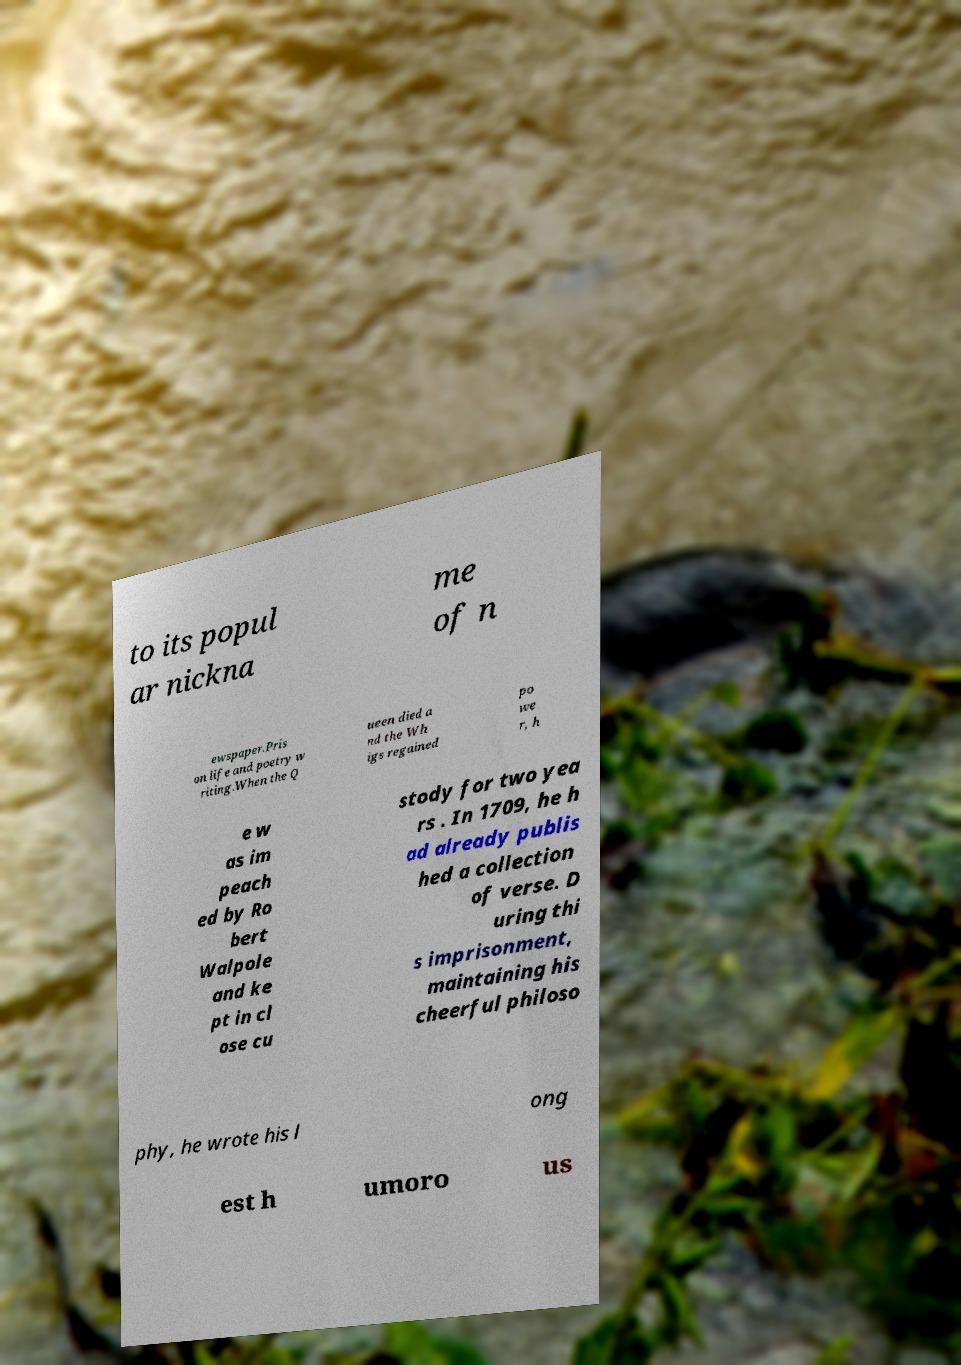Could you assist in decoding the text presented in this image and type it out clearly? to its popul ar nickna me of n ewspaper.Pris on life and poetry w riting.When the Q ueen died a nd the Wh igs regained po we r, h e w as im peach ed by Ro bert Walpole and ke pt in cl ose cu stody for two yea rs . In 1709, he h ad already publis hed a collection of verse. D uring thi s imprisonment, maintaining his cheerful philoso phy, he wrote his l ong est h umoro us 